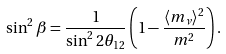Convert formula to latex. <formula><loc_0><loc_0><loc_500><loc_500>\sin ^ { 2 } \beta = \frac { 1 } { \sin ^ { 2 } { 2 \theta _ { 1 2 } } } \left ( 1 - \frac { \langle m _ { \nu } \rangle ^ { 2 } } { m ^ { 2 } } \right ) .</formula> 